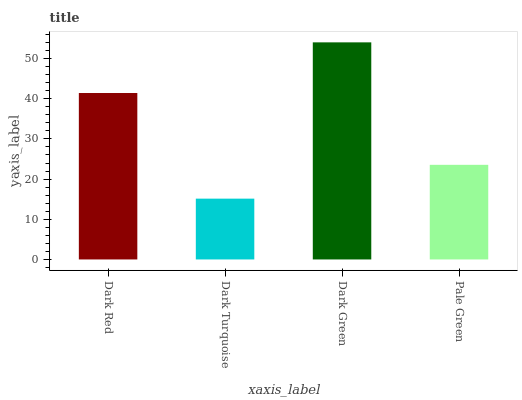Is Dark Turquoise the minimum?
Answer yes or no. Yes. Is Dark Green the maximum?
Answer yes or no. Yes. Is Dark Green the minimum?
Answer yes or no. No. Is Dark Turquoise the maximum?
Answer yes or no. No. Is Dark Green greater than Dark Turquoise?
Answer yes or no. Yes. Is Dark Turquoise less than Dark Green?
Answer yes or no. Yes. Is Dark Turquoise greater than Dark Green?
Answer yes or no. No. Is Dark Green less than Dark Turquoise?
Answer yes or no. No. Is Dark Red the high median?
Answer yes or no. Yes. Is Pale Green the low median?
Answer yes or no. Yes. Is Pale Green the high median?
Answer yes or no. No. Is Dark Turquoise the low median?
Answer yes or no. No. 